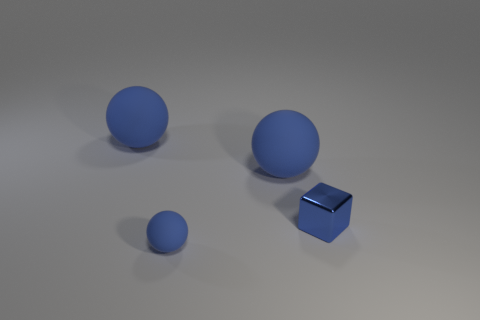How many blue spheres must be subtracted to get 1 blue spheres? 2 Subtract all large blue rubber balls. How many balls are left? 1 Add 3 large blue matte spheres. How many objects exist? 7 Subtract all blocks. How many objects are left? 3 Subtract all red cylinders. How many red balls are left? 0 Subtract all big blue balls. Subtract all tiny blue rubber spheres. How many objects are left? 1 Add 4 blue balls. How many blue balls are left? 7 Add 3 blue metallic objects. How many blue metallic objects exist? 4 Subtract 0 yellow spheres. How many objects are left? 4 Subtract 2 balls. How many balls are left? 1 